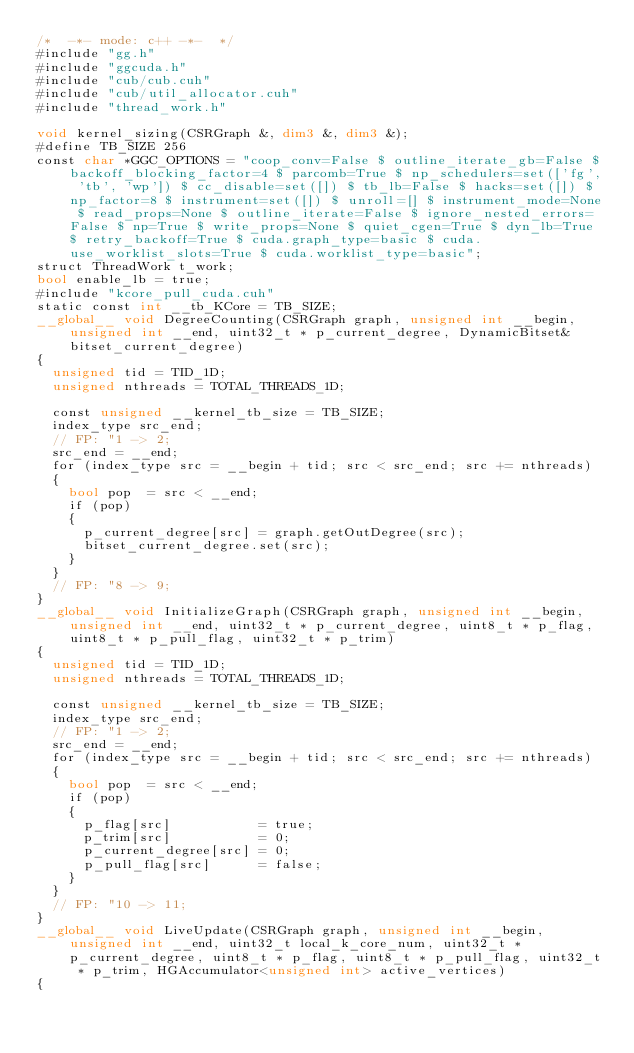<code> <loc_0><loc_0><loc_500><loc_500><_Cuda_>/*  -*- mode: c++ -*-  */
#include "gg.h"
#include "ggcuda.h"
#include "cub/cub.cuh"
#include "cub/util_allocator.cuh"
#include "thread_work.h"

void kernel_sizing(CSRGraph &, dim3 &, dim3 &);
#define TB_SIZE 256
const char *GGC_OPTIONS = "coop_conv=False $ outline_iterate_gb=False $ backoff_blocking_factor=4 $ parcomb=True $ np_schedulers=set(['fg', 'tb', 'wp']) $ cc_disable=set([]) $ tb_lb=False $ hacks=set([]) $ np_factor=8 $ instrument=set([]) $ unroll=[] $ instrument_mode=None $ read_props=None $ outline_iterate=False $ ignore_nested_errors=False $ np=True $ write_props=None $ quiet_cgen=True $ dyn_lb=True $ retry_backoff=True $ cuda.graph_type=basic $ cuda.use_worklist_slots=True $ cuda.worklist_type=basic";
struct ThreadWork t_work;
bool enable_lb = true;
#include "kcore_pull_cuda.cuh"
static const int __tb_KCore = TB_SIZE;
__global__ void DegreeCounting(CSRGraph graph, unsigned int __begin, unsigned int __end, uint32_t * p_current_degree, DynamicBitset& bitset_current_degree)
{
  unsigned tid = TID_1D;
  unsigned nthreads = TOTAL_THREADS_1D;

  const unsigned __kernel_tb_size = TB_SIZE;
  index_type src_end;
  // FP: "1 -> 2;
  src_end = __end;
  for (index_type src = __begin + tid; src < src_end; src += nthreads)
  {
    bool pop  = src < __end;
    if (pop)
    {
      p_current_degree[src] = graph.getOutDegree(src);
      bitset_current_degree.set(src);
    }
  }
  // FP: "8 -> 9;
}
__global__ void InitializeGraph(CSRGraph graph, unsigned int __begin, unsigned int __end, uint32_t * p_current_degree, uint8_t * p_flag, uint8_t * p_pull_flag, uint32_t * p_trim)
{
  unsigned tid = TID_1D;
  unsigned nthreads = TOTAL_THREADS_1D;

  const unsigned __kernel_tb_size = TB_SIZE;
  index_type src_end;
  // FP: "1 -> 2;
  src_end = __end;
  for (index_type src = __begin + tid; src < src_end; src += nthreads)
  {
    bool pop  = src < __end;
    if (pop)
    {
      p_flag[src]           = true;
      p_trim[src]           = 0;
      p_current_degree[src] = 0;
      p_pull_flag[src]      = false;
    }
  }
  // FP: "10 -> 11;
}
__global__ void LiveUpdate(CSRGraph graph, unsigned int __begin, unsigned int __end, uint32_t local_k_core_num, uint32_t * p_current_degree, uint8_t * p_flag, uint8_t * p_pull_flag, uint32_t * p_trim, HGAccumulator<unsigned int> active_vertices)
{</code> 